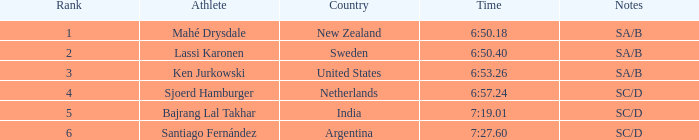What is the aggregate of ranks for india? 5.0. 